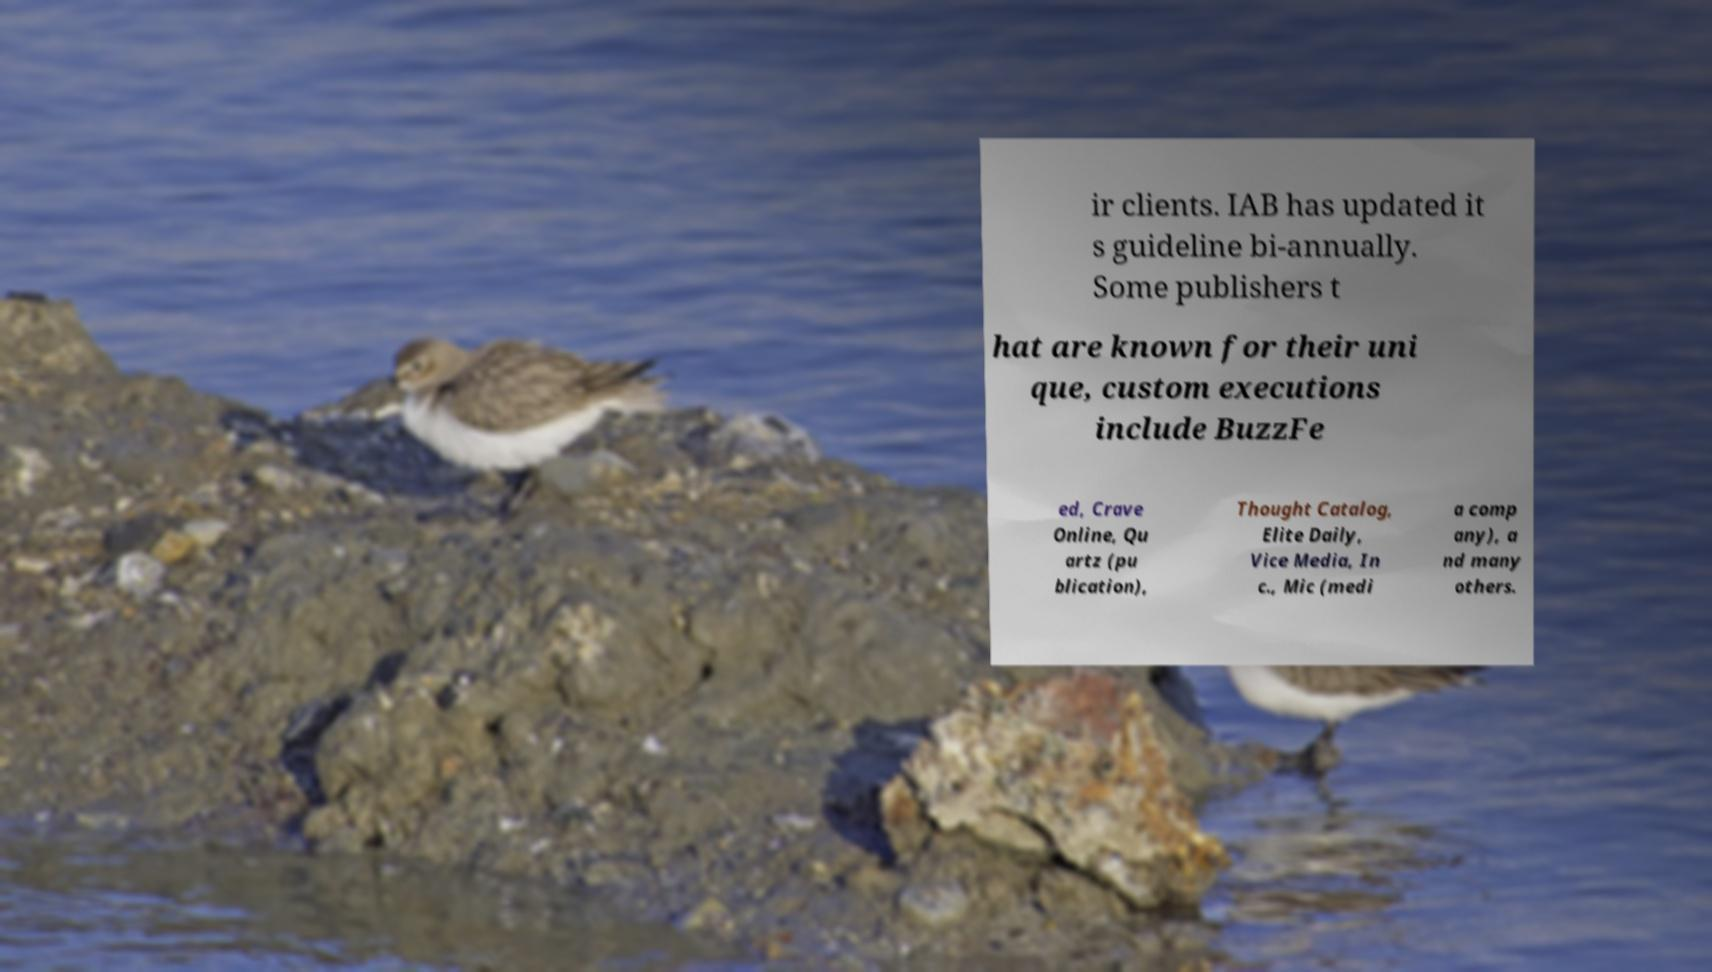Can you read and provide the text displayed in the image?This photo seems to have some interesting text. Can you extract and type it out for me? ir clients. IAB has updated it s guideline bi-annually. Some publishers t hat are known for their uni que, custom executions include BuzzFe ed, Crave Online, Qu artz (pu blication), Thought Catalog, Elite Daily, Vice Media, In c., Mic (medi a comp any), a nd many others. 